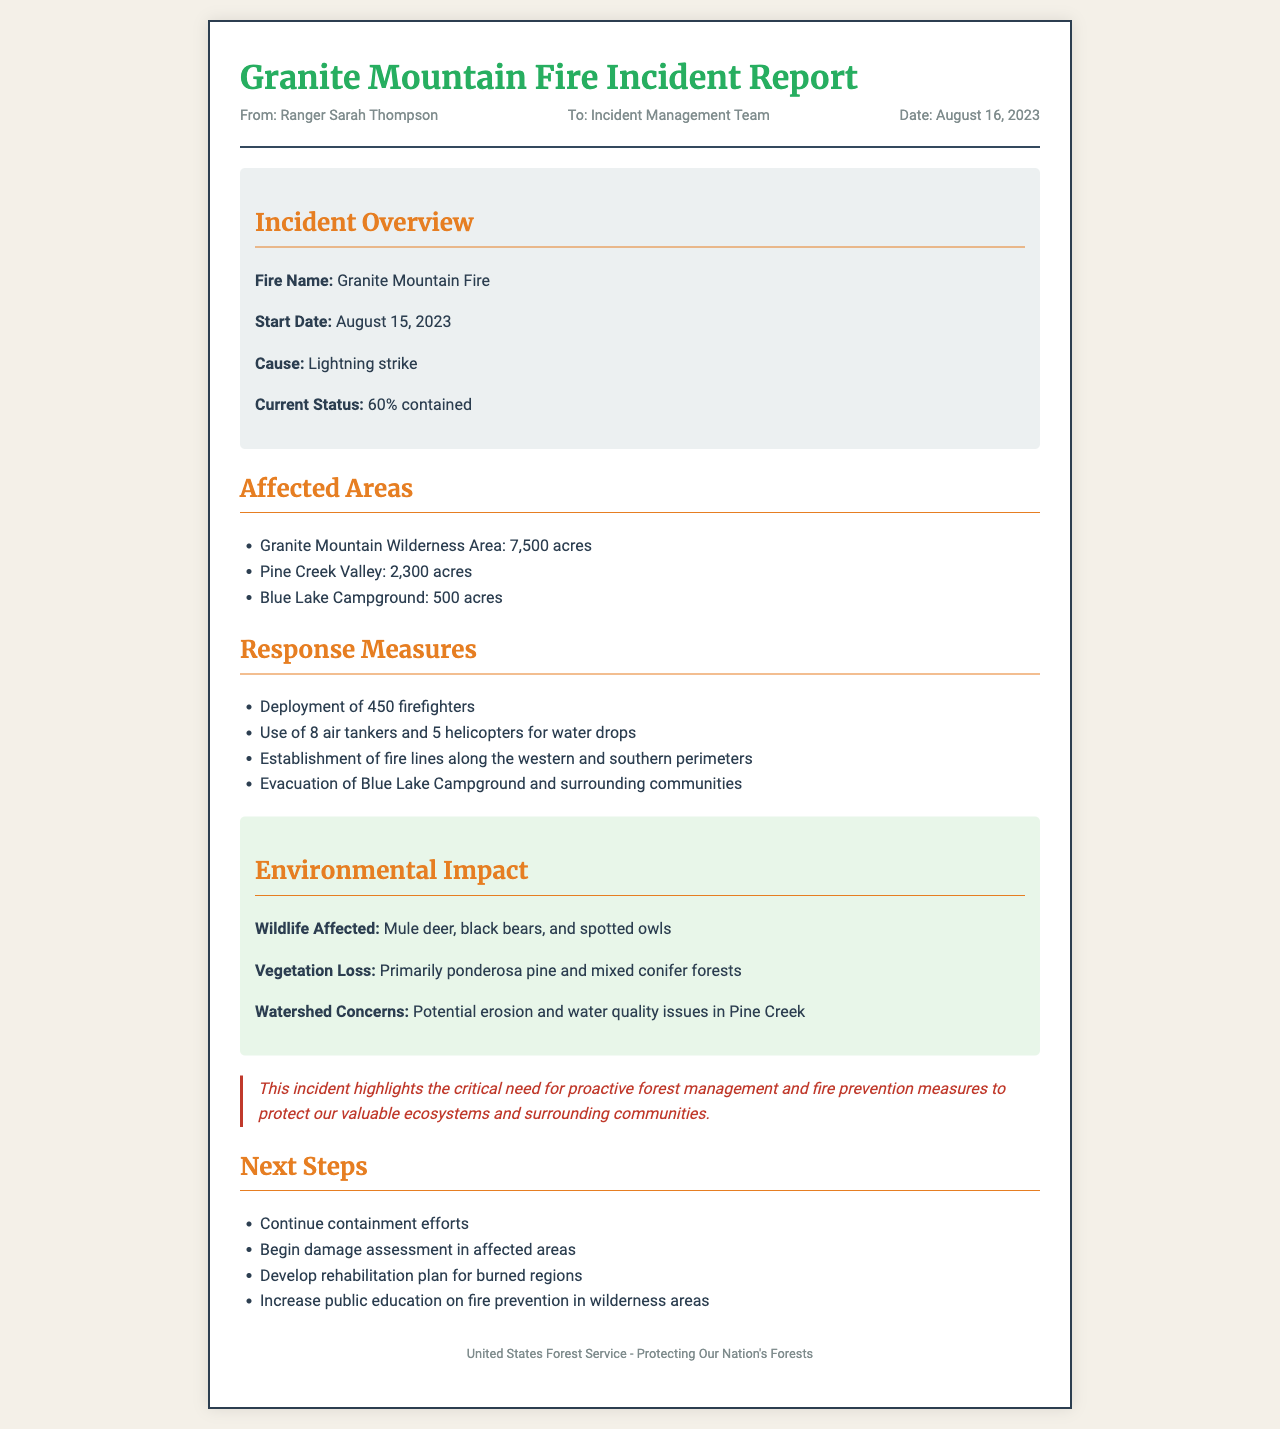what is the fire name? The fire name is stated in the incident overview section of the document.
Answer: Granite Mountain Fire when did the fire start? The start date of the fire is mentioned in the incident overview section.
Answer: August 15, 2023 how many acres were affected in Pine Creek Valley? The affected area for Pine Creek Valley is listed specifically in the affected areas section.
Answer: 2,300 acres what percentage of the fire is currently contained? The current status section of the incident overview provides the containment percentage.
Answer: 60% how many firefighters were deployed? The response measures outline the number of firefighters deployed to combat the fire.
Answer: 450 firefighters what is one wildlife species affected by the fire? The environmental impact section lists various wildlife affected by the fire.
Answer: Mule deer what is the main cause of the fire? The cause of the Granite Mountain Fire is mentioned in the incident overview.
Answer: Lightning strike what are the next steps after the incident? The next steps to be taken after the incident are listed in the respective section of the document.
Answer: Continue containment efforts what is the main conservation message highlighted in the report? The conservation message is emphasized in a specific section intended to stress forest management and fire prevention.
Answer: Proactive forest management and fire prevention measures 